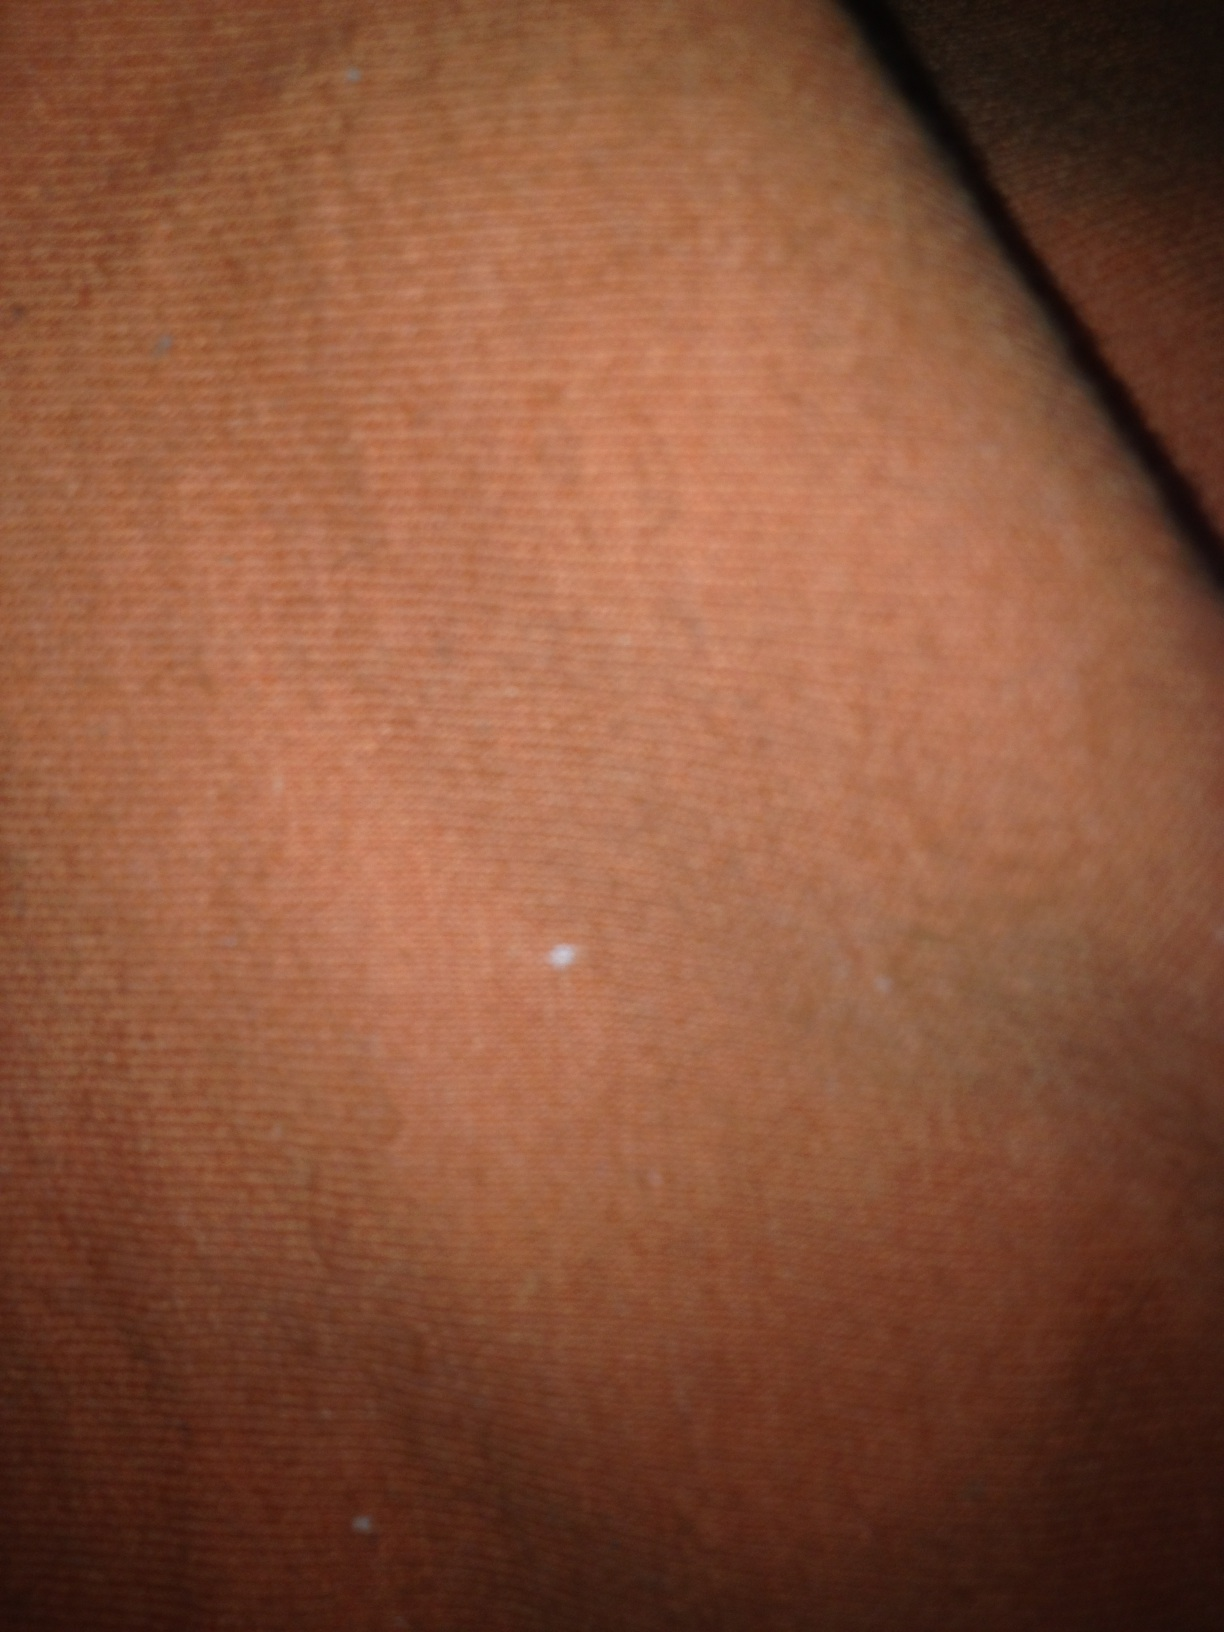What material might this be? This orange material appears to be a type of fabric. The texture and color suggest it could be cotton or another woven textile. Can you describe the texture of this fabric? The texture of the fabric in this image seems to be slightly rough and tightly woven. There are visible threads and small imperfections, which could indicate a natural fiber like cotton. What scenarios could this fabric be used in? This type of fabric could be used in various scenarios, such as in making clothing like shirts or pants, home furnishings like curtains or pillow covers, or even in crafting projects like quilts or bags. 